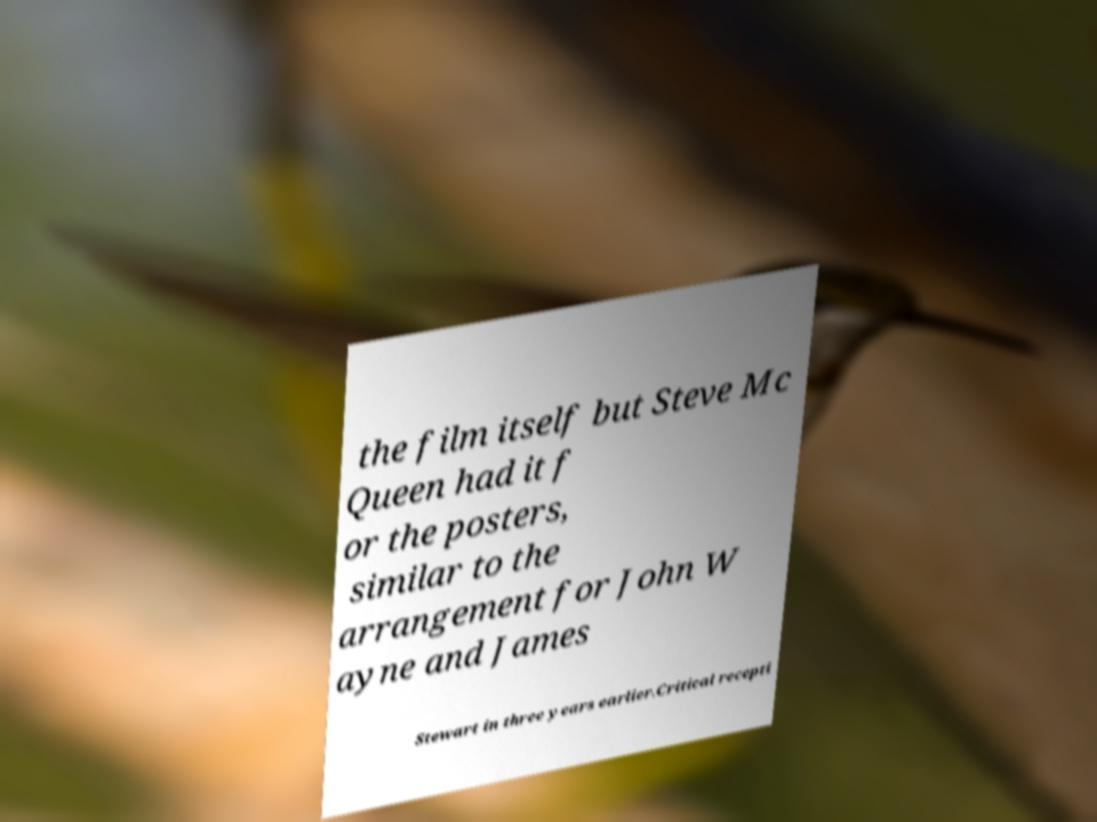Can you read and provide the text displayed in the image?This photo seems to have some interesting text. Can you extract and type it out for me? the film itself but Steve Mc Queen had it f or the posters, similar to the arrangement for John W ayne and James Stewart in three years earlier.Critical recepti 